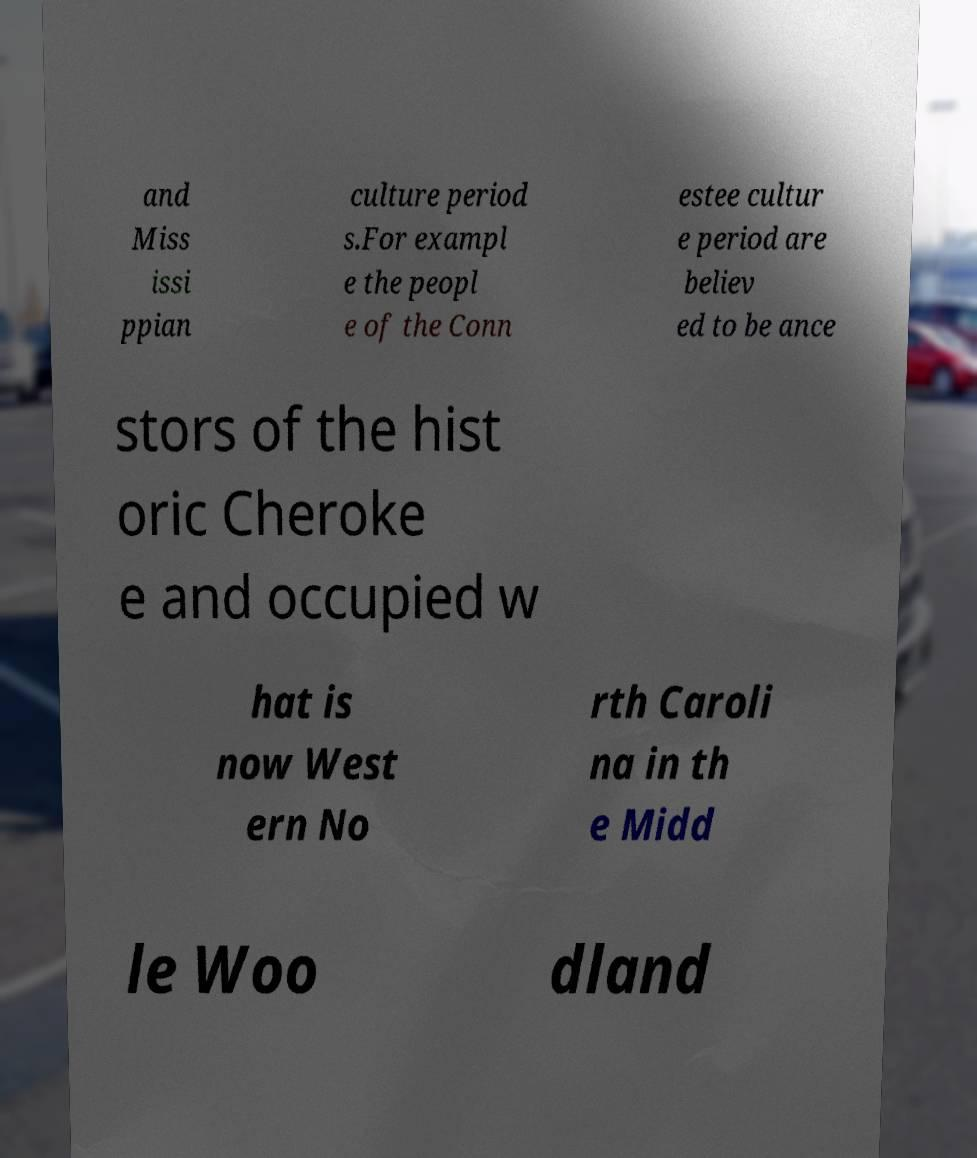Can you accurately transcribe the text from the provided image for me? and Miss issi ppian culture period s.For exampl e the peopl e of the Conn estee cultur e period are believ ed to be ance stors of the hist oric Cheroke e and occupied w hat is now West ern No rth Caroli na in th e Midd le Woo dland 